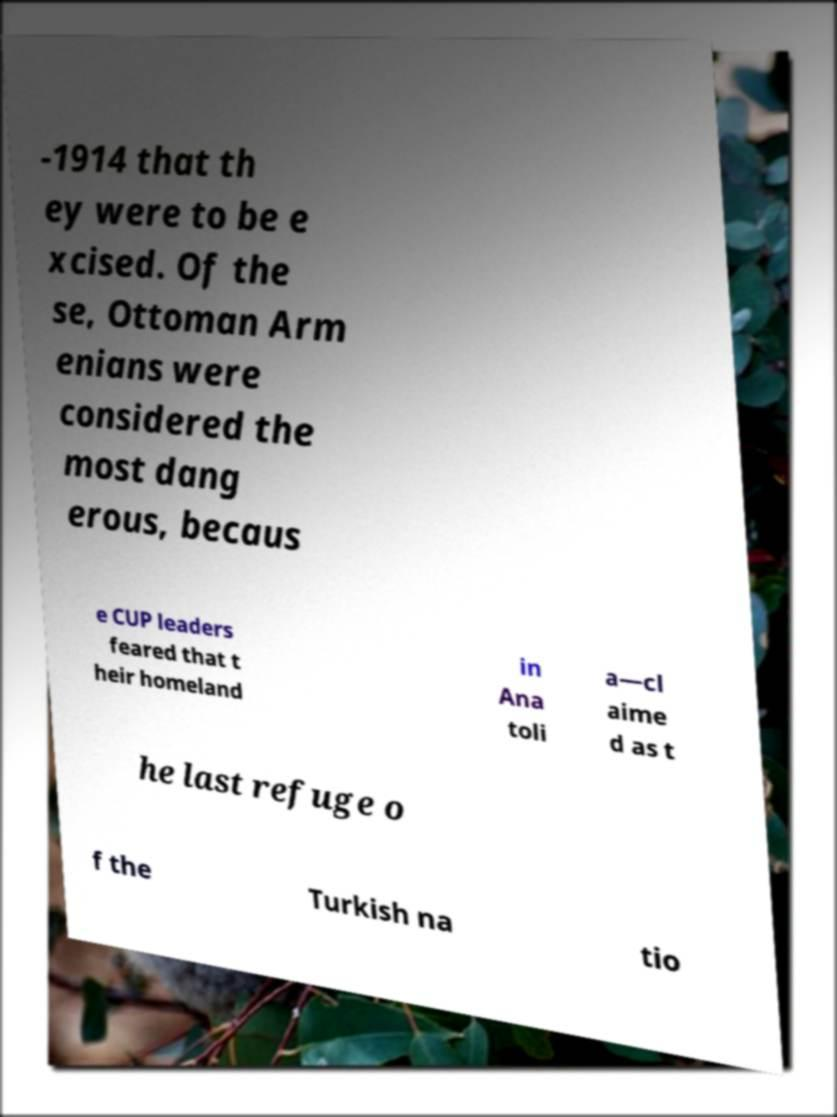Could you assist in decoding the text presented in this image and type it out clearly? -1914 that th ey were to be e xcised. Of the se, Ottoman Arm enians were considered the most dang erous, becaus e CUP leaders feared that t heir homeland in Ana toli a—cl aime d as t he last refuge o f the Turkish na tio 